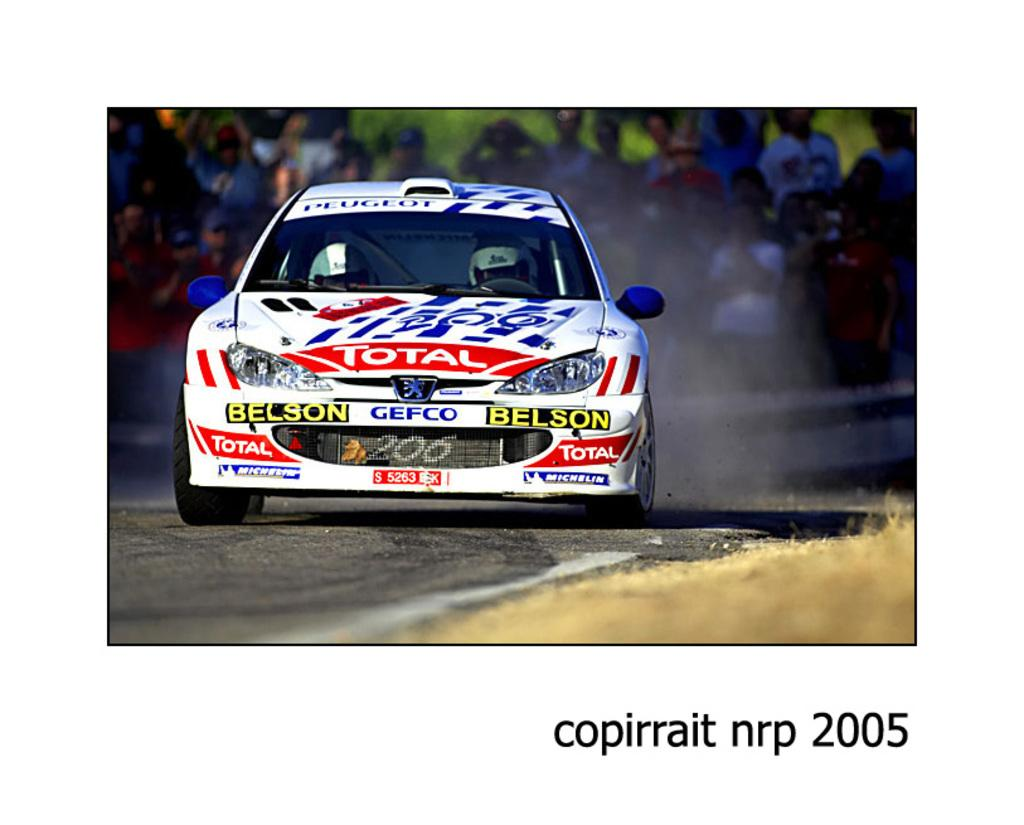What is the main subject of the image? There is a car in the center of the image. Where is the car located? The car is on the road. What else can be seen in the background of the image? There are people standing in the background of the image. Is there any text present in the image? Yes, there is text written at the bottom of the image. What type of frame is surrounding the car in the image? There is no frame surrounding the car in the image; it is a photograph or digital image without a physical frame. 